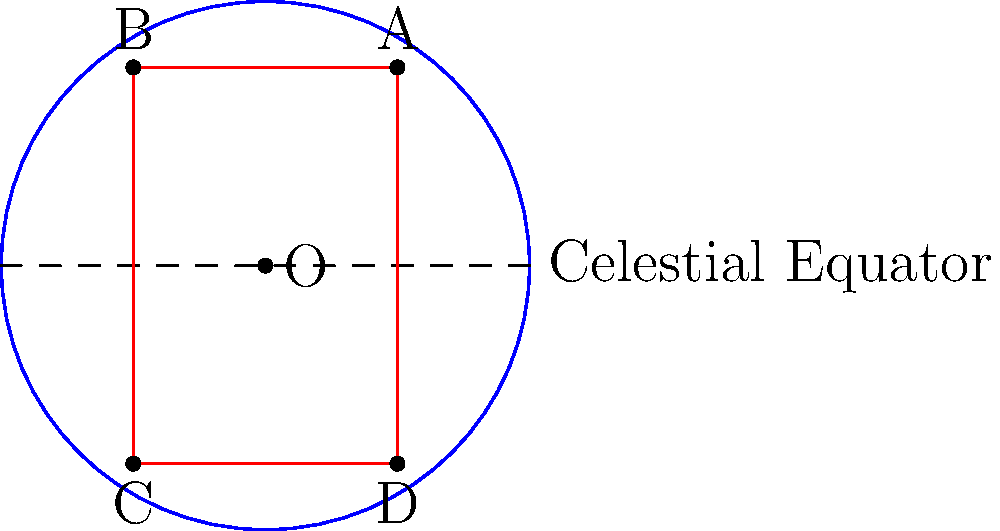In the celestial sphere diagram, points A, B, C, and D represent celestial bodies. If we reflect these points across the celestial equator, what philosophical concept might this transformation symbolize, and how would it affect the coordinates of point A? To answer this question, let's approach it step-by-step:

1. Geometrical perspective:
   - The celestial equator divides the celestial sphere into two hemispheres.
   - Reflection across the celestial equator means flipping a point from one hemisphere to the other.

2. For point A (2,3):
   - Its reflection would be (2,-3), which is point D.
   - Mathematically, this is achieved by negating the y-coordinate.

3. Philosophical interpretation:
   - This reflection symbolizes the concept of duality or complementarity in philosophy.
   - It suggests that for every aspect of reality, there exists an opposite or complementary aspect.

4. Astrological perspective:
   - In astrology, this could represent the balance between opposing forces or energies.
   - It might symbolize the idea that our destiny is influenced by both "above" and "below" celestial energies.

5. Impact on human perception of destiny:
   - This transformation implies that our fate might be viewed from multiple perspectives.
   - It suggests that what appears as one thing from our vantage point might have an equal and opposite manifestation from another viewpoint.

6. Coordinates transformation:
   - Original coordinates of A: (2,3)
   - Reflected coordinates: (2,-3)
   - The x-coordinate remains unchanged, while the y-coordinate is negated.

This reflection across the celestial equator thus symbolizes a philosophical concept of duality or complementarity, suggesting that our perception of destiny might be influenced by considering both the visible and hidden aspects of celestial influences.
Answer: Duality; A(2,3) → A'(2,-3) 